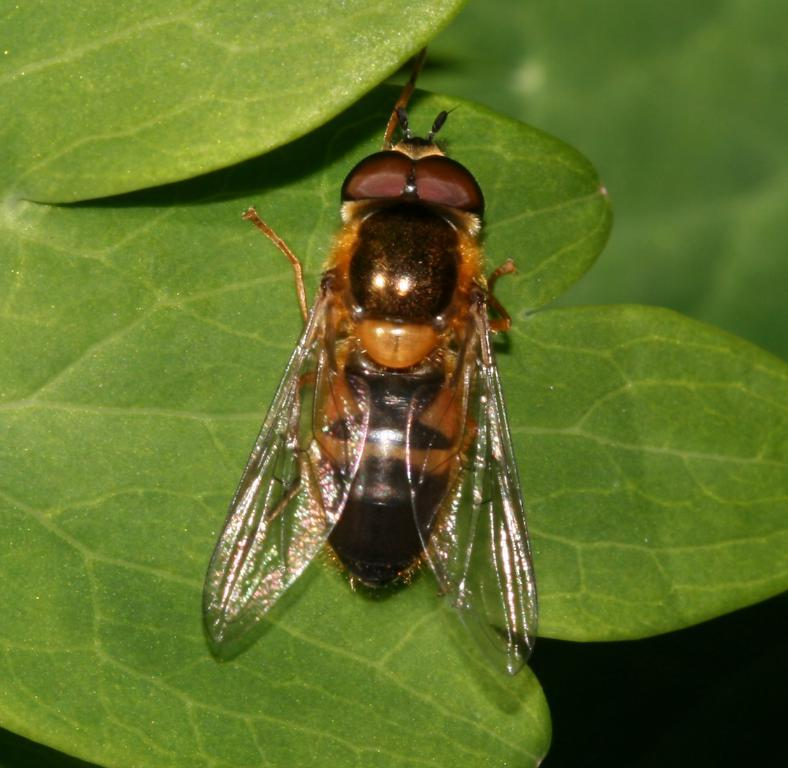What is present in the image? There is a fly in the image. Where is the fly located? The fly is on a leaf. What unit of measurement is used to describe the fly's route in the image? There is no route or unit of measurement mentioned in the image, as it only shows a fly on a leaf. 